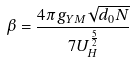<formula> <loc_0><loc_0><loc_500><loc_500>\beta = \frac { 4 \pi g _ { Y M } \sqrt { d _ { 0 } N } } { 7 U _ { H } ^ { \frac { 5 } { 2 } } }</formula> 